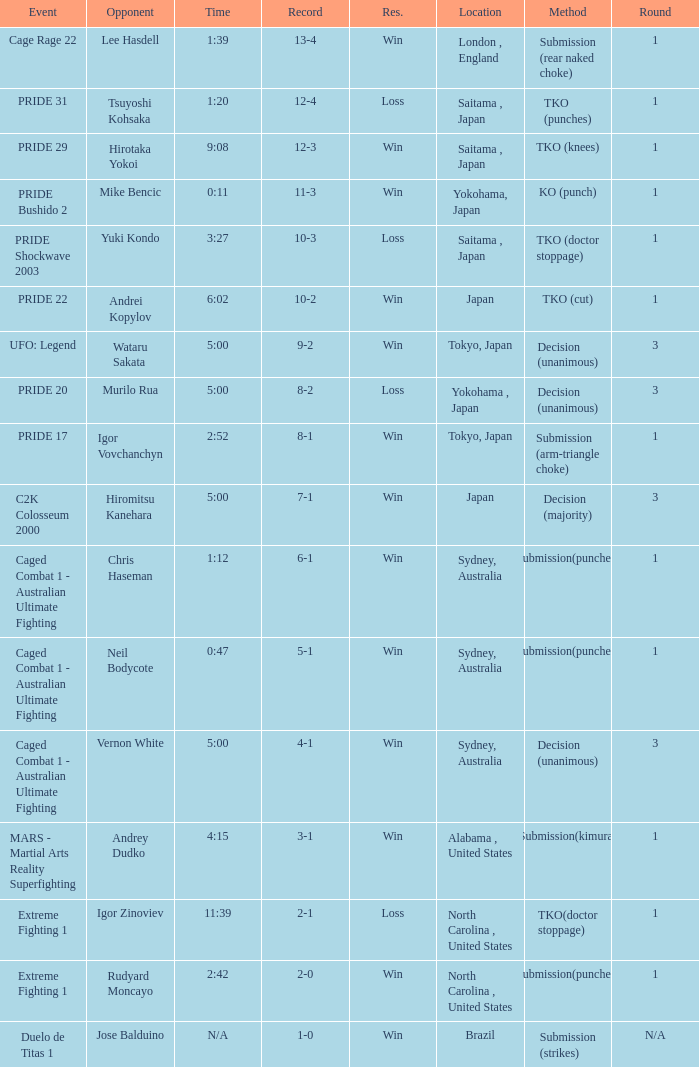Which Res has a Method of decision (unanimous) and an Opponent of Wataru Sakata? Win. 